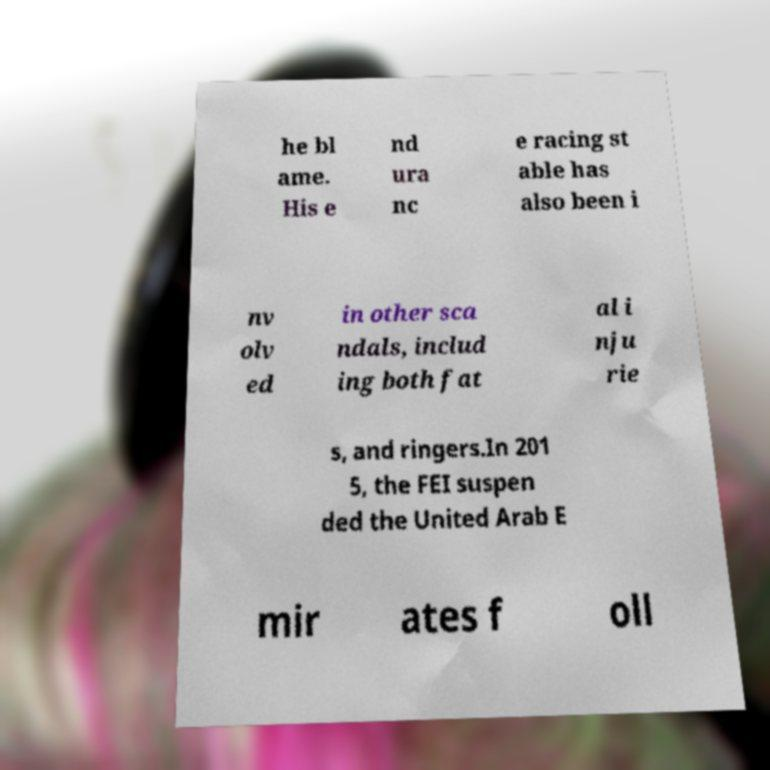There's text embedded in this image that I need extracted. Can you transcribe it verbatim? he bl ame. His e nd ura nc e racing st able has also been i nv olv ed in other sca ndals, includ ing both fat al i nju rie s, and ringers.In 201 5, the FEI suspen ded the United Arab E mir ates f oll 